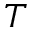Convert formula to latex. <formula><loc_0><loc_0><loc_500><loc_500>T</formula> 